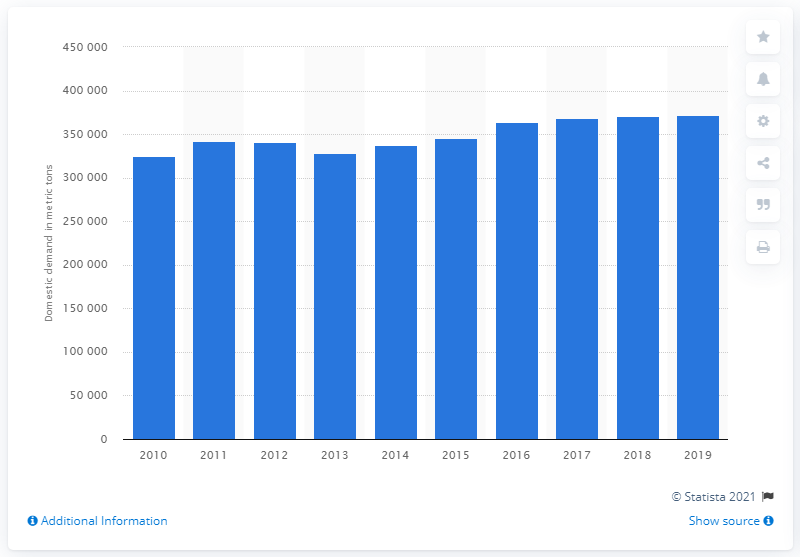Indicate a few pertinent items in this graphic. In 2019, the domestic demand for acrylonitrile butadiene styrene resin in South Korea was 371,411 metric tons. 